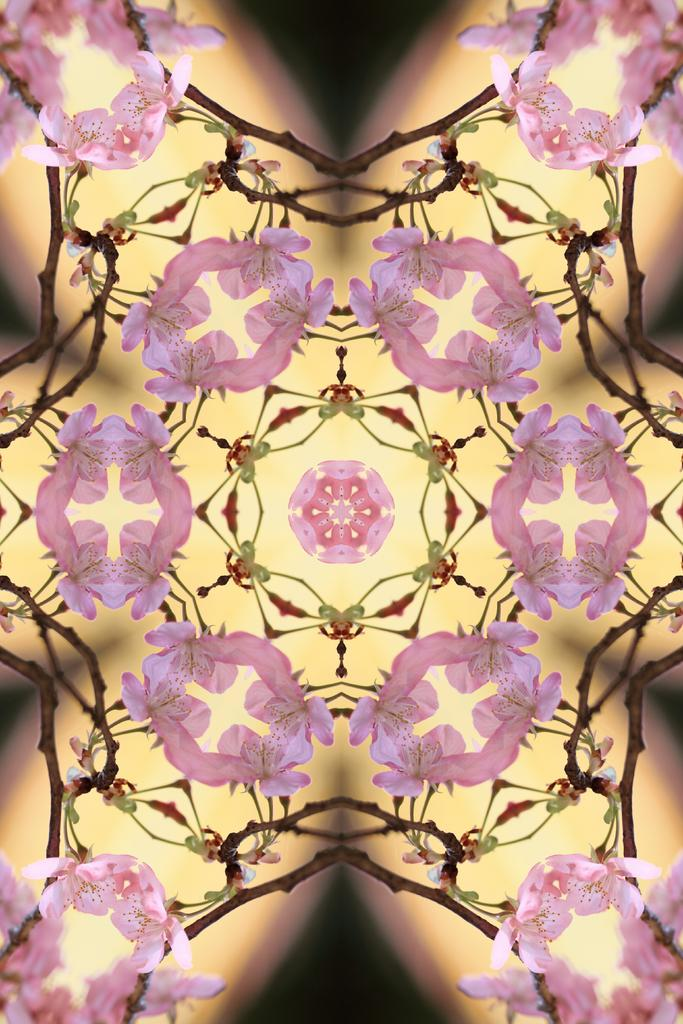What can be seen in the image related to illumination? There is a light in the image. What is unique about the light in the image? The light has a design on it. Where is the design located on the light? The design is in the center of the light. How does the light interact with the bubbles in the image? There are no bubbles present in the image, so the light does not interact with any bubbles. 